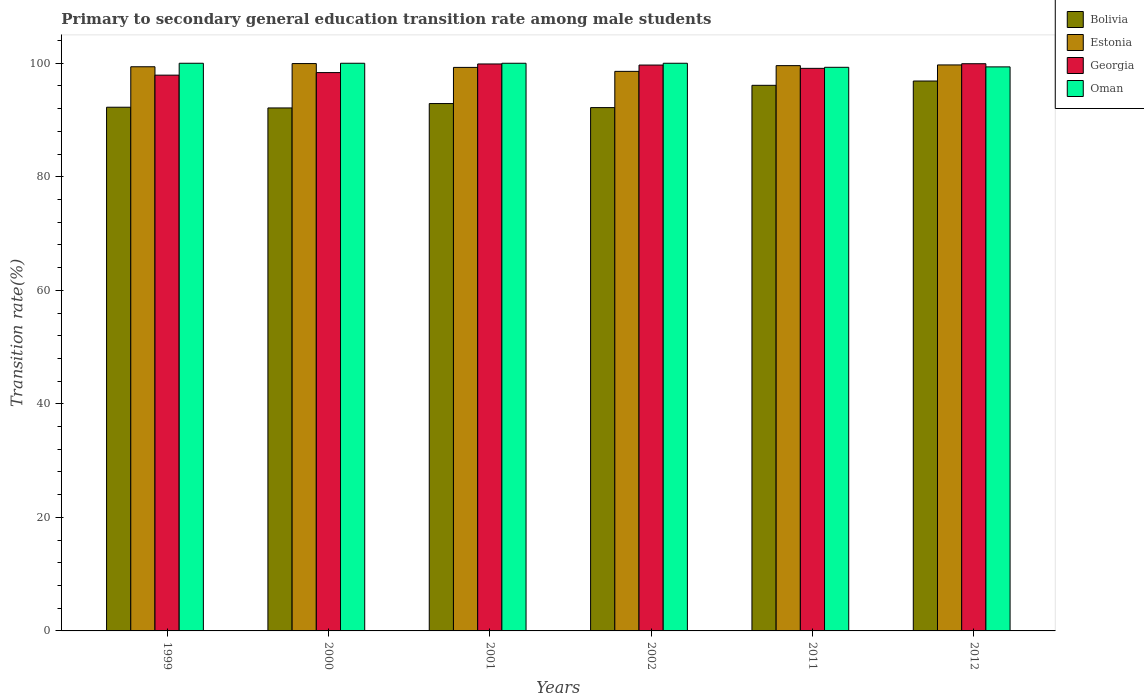How many different coloured bars are there?
Offer a very short reply. 4. How many groups of bars are there?
Give a very brief answer. 6. Are the number of bars per tick equal to the number of legend labels?
Ensure brevity in your answer.  Yes. How many bars are there on the 4th tick from the left?
Make the answer very short. 4. Across all years, what is the maximum transition rate in Estonia?
Your response must be concise. 99.94. Across all years, what is the minimum transition rate in Estonia?
Ensure brevity in your answer.  98.57. What is the total transition rate in Oman in the graph?
Provide a short and direct response. 598.65. What is the difference between the transition rate in Estonia in 2002 and that in 2012?
Make the answer very short. -1.13. What is the difference between the transition rate in Oman in 2011 and the transition rate in Georgia in 1999?
Offer a very short reply. 1.38. What is the average transition rate in Georgia per year?
Keep it short and to the point. 99.14. In the year 2002, what is the difference between the transition rate in Bolivia and transition rate in Georgia?
Keep it short and to the point. -7.5. In how many years, is the transition rate in Estonia greater than 24 %?
Make the answer very short. 6. What is the ratio of the transition rate in Bolivia in 1999 to that in 2011?
Make the answer very short. 0.96. What is the difference between the highest and the second highest transition rate in Bolivia?
Your answer should be very brief. 0.76. What is the difference between the highest and the lowest transition rate in Oman?
Your answer should be compact. 0.71. In how many years, is the transition rate in Estonia greater than the average transition rate in Estonia taken over all years?
Your response must be concise. 3. Is the sum of the transition rate in Georgia in 2001 and 2011 greater than the maximum transition rate in Estonia across all years?
Provide a succinct answer. Yes. Is it the case that in every year, the sum of the transition rate in Bolivia and transition rate in Oman is greater than the sum of transition rate in Georgia and transition rate in Estonia?
Keep it short and to the point. No. What does the 1st bar from the left in 1999 represents?
Ensure brevity in your answer.  Bolivia. What does the 2nd bar from the right in 1999 represents?
Offer a very short reply. Georgia. Is it the case that in every year, the sum of the transition rate in Georgia and transition rate in Oman is greater than the transition rate in Estonia?
Offer a very short reply. Yes. How many bars are there?
Provide a short and direct response. 24. Are all the bars in the graph horizontal?
Your response must be concise. No. Does the graph contain any zero values?
Your answer should be compact. No. Where does the legend appear in the graph?
Ensure brevity in your answer.  Top right. How many legend labels are there?
Ensure brevity in your answer.  4. What is the title of the graph?
Your answer should be compact. Primary to secondary general education transition rate among male students. Does "Turks and Caicos Islands" appear as one of the legend labels in the graph?
Provide a succinct answer. No. What is the label or title of the X-axis?
Offer a terse response. Years. What is the label or title of the Y-axis?
Make the answer very short. Transition rate(%). What is the Transition rate(%) in Bolivia in 1999?
Provide a short and direct response. 92.25. What is the Transition rate(%) of Estonia in 1999?
Ensure brevity in your answer.  99.38. What is the Transition rate(%) of Georgia in 1999?
Make the answer very short. 97.91. What is the Transition rate(%) in Oman in 1999?
Give a very brief answer. 100. What is the Transition rate(%) of Bolivia in 2000?
Ensure brevity in your answer.  92.13. What is the Transition rate(%) in Estonia in 2000?
Your response must be concise. 99.94. What is the Transition rate(%) of Georgia in 2000?
Offer a very short reply. 98.36. What is the Transition rate(%) in Oman in 2000?
Provide a succinct answer. 100. What is the Transition rate(%) of Bolivia in 2001?
Give a very brief answer. 92.9. What is the Transition rate(%) in Estonia in 2001?
Provide a short and direct response. 99.27. What is the Transition rate(%) in Georgia in 2001?
Make the answer very short. 99.88. What is the Transition rate(%) of Oman in 2001?
Ensure brevity in your answer.  100. What is the Transition rate(%) in Bolivia in 2002?
Provide a short and direct response. 92.19. What is the Transition rate(%) in Estonia in 2002?
Make the answer very short. 98.57. What is the Transition rate(%) in Georgia in 2002?
Provide a succinct answer. 99.68. What is the Transition rate(%) of Bolivia in 2011?
Your response must be concise. 96.11. What is the Transition rate(%) in Estonia in 2011?
Provide a short and direct response. 99.58. What is the Transition rate(%) of Georgia in 2011?
Provide a short and direct response. 99.1. What is the Transition rate(%) of Oman in 2011?
Give a very brief answer. 99.29. What is the Transition rate(%) in Bolivia in 2012?
Your answer should be very brief. 96.87. What is the Transition rate(%) of Estonia in 2012?
Offer a very short reply. 99.71. What is the Transition rate(%) in Georgia in 2012?
Make the answer very short. 99.92. What is the Transition rate(%) of Oman in 2012?
Your answer should be very brief. 99.36. Across all years, what is the maximum Transition rate(%) of Bolivia?
Make the answer very short. 96.87. Across all years, what is the maximum Transition rate(%) in Estonia?
Make the answer very short. 99.94. Across all years, what is the maximum Transition rate(%) of Georgia?
Your answer should be very brief. 99.92. Across all years, what is the maximum Transition rate(%) of Oman?
Provide a succinct answer. 100. Across all years, what is the minimum Transition rate(%) in Bolivia?
Your response must be concise. 92.13. Across all years, what is the minimum Transition rate(%) of Estonia?
Provide a short and direct response. 98.57. Across all years, what is the minimum Transition rate(%) of Georgia?
Ensure brevity in your answer.  97.91. Across all years, what is the minimum Transition rate(%) in Oman?
Make the answer very short. 99.29. What is the total Transition rate(%) of Bolivia in the graph?
Offer a terse response. 562.46. What is the total Transition rate(%) of Estonia in the graph?
Provide a short and direct response. 596.46. What is the total Transition rate(%) in Georgia in the graph?
Offer a very short reply. 594.84. What is the total Transition rate(%) of Oman in the graph?
Ensure brevity in your answer.  598.65. What is the difference between the Transition rate(%) of Bolivia in 1999 and that in 2000?
Offer a terse response. 0.13. What is the difference between the Transition rate(%) in Estonia in 1999 and that in 2000?
Make the answer very short. -0.56. What is the difference between the Transition rate(%) of Georgia in 1999 and that in 2000?
Your response must be concise. -0.45. What is the difference between the Transition rate(%) of Oman in 1999 and that in 2000?
Offer a very short reply. 0. What is the difference between the Transition rate(%) in Bolivia in 1999 and that in 2001?
Give a very brief answer. -0.65. What is the difference between the Transition rate(%) in Estonia in 1999 and that in 2001?
Provide a short and direct response. 0.11. What is the difference between the Transition rate(%) in Georgia in 1999 and that in 2001?
Provide a short and direct response. -1.97. What is the difference between the Transition rate(%) of Bolivia in 1999 and that in 2002?
Your answer should be very brief. 0.06. What is the difference between the Transition rate(%) in Estonia in 1999 and that in 2002?
Ensure brevity in your answer.  0.81. What is the difference between the Transition rate(%) in Georgia in 1999 and that in 2002?
Your answer should be very brief. -1.78. What is the difference between the Transition rate(%) of Bolivia in 1999 and that in 2011?
Provide a succinct answer. -3.86. What is the difference between the Transition rate(%) of Estonia in 1999 and that in 2011?
Your answer should be compact. -0.2. What is the difference between the Transition rate(%) of Georgia in 1999 and that in 2011?
Ensure brevity in your answer.  -1.2. What is the difference between the Transition rate(%) of Oman in 1999 and that in 2011?
Provide a succinct answer. 0.71. What is the difference between the Transition rate(%) in Bolivia in 1999 and that in 2012?
Provide a succinct answer. -4.62. What is the difference between the Transition rate(%) of Estonia in 1999 and that in 2012?
Provide a succinct answer. -0.32. What is the difference between the Transition rate(%) of Georgia in 1999 and that in 2012?
Provide a succinct answer. -2.01. What is the difference between the Transition rate(%) of Oman in 1999 and that in 2012?
Keep it short and to the point. 0.64. What is the difference between the Transition rate(%) in Bolivia in 2000 and that in 2001?
Give a very brief answer. -0.77. What is the difference between the Transition rate(%) of Estonia in 2000 and that in 2001?
Give a very brief answer. 0.67. What is the difference between the Transition rate(%) of Georgia in 2000 and that in 2001?
Ensure brevity in your answer.  -1.52. What is the difference between the Transition rate(%) in Oman in 2000 and that in 2001?
Make the answer very short. 0. What is the difference between the Transition rate(%) in Bolivia in 2000 and that in 2002?
Give a very brief answer. -0.06. What is the difference between the Transition rate(%) of Estonia in 2000 and that in 2002?
Your response must be concise. 1.37. What is the difference between the Transition rate(%) in Georgia in 2000 and that in 2002?
Ensure brevity in your answer.  -1.33. What is the difference between the Transition rate(%) in Bolivia in 2000 and that in 2011?
Your answer should be very brief. -3.99. What is the difference between the Transition rate(%) of Estonia in 2000 and that in 2011?
Give a very brief answer. 0.36. What is the difference between the Transition rate(%) in Georgia in 2000 and that in 2011?
Give a very brief answer. -0.74. What is the difference between the Transition rate(%) in Oman in 2000 and that in 2011?
Offer a terse response. 0.71. What is the difference between the Transition rate(%) of Bolivia in 2000 and that in 2012?
Offer a very short reply. -4.74. What is the difference between the Transition rate(%) of Estonia in 2000 and that in 2012?
Provide a succinct answer. 0.24. What is the difference between the Transition rate(%) in Georgia in 2000 and that in 2012?
Make the answer very short. -1.56. What is the difference between the Transition rate(%) of Oman in 2000 and that in 2012?
Offer a terse response. 0.64. What is the difference between the Transition rate(%) of Bolivia in 2001 and that in 2002?
Ensure brevity in your answer.  0.71. What is the difference between the Transition rate(%) in Estonia in 2001 and that in 2002?
Your answer should be compact. 0.7. What is the difference between the Transition rate(%) of Georgia in 2001 and that in 2002?
Offer a very short reply. 0.19. What is the difference between the Transition rate(%) in Bolivia in 2001 and that in 2011?
Offer a very short reply. -3.21. What is the difference between the Transition rate(%) in Estonia in 2001 and that in 2011?
Make the answer very short. -0.31. What is the difference between the Transition rate(%) of Georgia in 2001 and that in 2011?
Your response must be concise. 0.77. What is the difference between the Transition rate(%) of Oman in 2001 and that in 2011?
Your answer should be very brief. 0.71. What is the difference between the Transition rate(%) in Bolivia in 2001 and that in 2012?
Provide a succinct answer. -3.97. What is the difference between the Transition rate(%) of Estonia in 2001 and that in 2012?
Offer a terse response. -0.44. What is the difference between the Transition rate(%) in Georgia in 2001 and that in 2012?
Your answer should be compact. -0.04. What is the difference between the Transition rate(%) of Oman in 2001 and that in 2012?
Offer a very short reply. 0.64. What is the difference between the Transition rate(%) of Bolivia in 2002 and that in 2011?
Ensure brevity in your answer.  -3.92. What is the difference between the Transition rate(%) in Estonia in 2002 and that in 2011?
Make the answer very short. -1.01. What is the difference between the Transition rate(%) of Georgia in 2002 and that in 2011?
Your response must be concise. 0.58. What is the difference between the Transition rate(%) in Oman in 2002 and that in 2011?
Ensure brevity in your answer.  0.71. What is the difference between the Transition rate(%) in Bolivia in 2002 and that in 2012?
Your answer should be compact. -4.68. What is the difference between the Transition rate(%) in Estonia in 2002 and that in 2012?
Make the answer very short. -1.13. What is the difference between the Transition rate(%) in Georgia in 2002 and that in 2012?
Keep it short and to the point. -0.23. What is the difference between the Transition rate(%) of Oman in 2002 and that in 2012?
Provide a short and direct response. 0.64. What is the difference between the Transition rate(%) of Bolivia in 2011 and that in 2012?
Provide a short and direct response. -0.76. What is the difference between the Transition rate(%) in Estonia in 2011 and that in 2012?
Your response must be concise. -0.12. What is the difference between the Transition rate(%) in Georgia in 2011 and that in 2012?
Your answer should be very brief. -0.82. What is the difference between the Transition rate(%) in Oman in 2011 and that in 2012?
Offer a very short reply. -0.08. What is the difference between the Transition rate(%) of Bolivia in 1999 and the Transition rate(%) of Estonia in 2000?
Your answer should be very brief. -7.69. What is the difference between the Transition rate(%) of Bolivia in 1999 and the Transition rate(%) of Georgia in 2000?
Your answer should be compact. -6.1. What is the difference between the Transition rate(%) of Bolivia in 1999 and the Transition rate(%) of Oman in 2000?
Your answer should be compact. -7.75. What is the difference between the Transition rate(%) in Estonia in 1999 and the Transition rate(%) in Georgia in 2000?
Your answer should be very brief. 1.02. What is the difference between the Transition rate(%) in Estonia in 1999 and the Transition rate(%) in Oman in 2000?
Offer a very short reply. -0.62. What is the difference between the Transition rate(%) of Georgia in 1999 and the Transition rate(%) of Oman in 2000?
Your answer should be compact. -2.09. What is the difference between the Transition rate(%) in Bolivia in 1999 and the Transition rate(%) in Estonia in 2001?
Offer a terse response. -7.02. What is the difference between the Transition rate(%) in Bolivia in 1999 and the Transition rate(%) in Georgia in 2001?
Your answer should be compact. -7.62. What is the difference between the Transition rate(%) in Bolivia in 1999 and the Transition rate(%) in Oman in 2001?
Keep it short and to the point. -7.75. What is the difference between the Transition rate(%) in Estonia in 1999 and the Transition rate(%) in Georgia in 2001?
Keep it short and to the point. -0.49. What is the difference between the Transition rate(%) in Estonia in 1999 and the Transition rate(%) in Oman in 2001?
Make the answer very short. -0.62. What is the difference between the Transition rate(%) in Georgia in 1999 and the Transition rate(%) in Oman in 2001?
Give a very brief answer. -2.09. What is the difference between the Transition rate(%) in Bolivia in 1999 and the Transition rate(%) in Estonia in 2002?
Ensure brevity in your answer.  -6.32. What is the difference between the Transition rate(%) in Bolivia in 1999 and the Transition rate(%) in Georgia in 2002?
Offer a terse response. -7.43. What is the difference between the Transition rate(%) in Bolivia in 1999 and the Transition rate(%) in Oman in 2002?
Give a very brief answer. -7.75. What is the difference between the Transition rate(%) of Estonia in 1999 and the Transition rate(%) of Georgia in 2002?
Offer a very short reply. -0.3. What is the difference between the Transition rate(%) in Estonia in 1999 and the Transition rate(%) in Oman in 2002?
Provide a short and direct response. -0.62. What is the difference between the Transition rate(%) of Georgia in 1999 and the Transition rate(%) of Oman in 2002?
Keep it short and to the point. -2.09. What is the difference between the Transition rate(%) in Bolivia in 1999 and the Transition rate(%) in Estonia in 2011?
Offer a very short reply. -7.33. What is the difference between the Transition rate(%) in Bolivia in 1999 and the Transition rate(%) in Georgia in 2011?
Give a very brief answer. -6.85. What is the difference between the Transition rate(%) in Bolivia in 1999 and the Transition rate(%) in Oman in 2011?
Ensure brevity in your answer.  -7.03. What is the difference between the Transition rate(%) in Estonia in 1999 and the Transition rate(%) in Georgia in 2011?
Provide a succinct answer. 0.28. What is the difference between the Transition rate(%) of Estonia in 1999 and the Transition rate(%) of Oman in 2011?
Your answer should be very brief. 0.1. What is the difference between the Transition rate(%) of Georgia in 1999 and the Transition rate(%) of Oman in 2011?
Keep it short and to the point. -1.38. What is the difference between the Transition rate(%) of Bolivia in 1999 and the Transition rate(%) of Estonia in 2012?
Provide a short and direct response. -7.45. What is the difference between the Transition rate(%) in Bolivia in 1999 and the Transition rate(%) in Georgia in 2012?
Provide a short and direct response. -7.66. What is the difference between the Transition rate(%) of Bolivia in 1999 and the Transition rate(%) of Oman in 2012?
Offer a very short reply. -7.11. What is the difference between the Transition rate(%) in Estonia in 1999 and the Transition rate(%) in Georgia in 2012?
Keep it short and to the point. -0.54. What is the difference between the Transition rate(%) in Estonia in 1999 and the Transition rate(%) in Oman in 2012?
Provide a short and direct response. 0.02. What is the difference between the Transition rate(%) of Georgia in 1999 and the Transition rate(%) of Oman in 2012?
Ensure brevity in your answer.  -1.46. What is the difference between the Transition rate(%) of Bolivia in 2000 and the Transition rate(%) of Estonia in 2001?
Offer a very short reply. -7.14. What is the difference between the Transition rate(%) in Bolivia in 2000 and the Transition rate(%) in Georgia in 2001?
Keep it short and to the point. -7.75. What is the difference between the Transition rate(%) in Bolivia in 2000 and the Transition rate(%) in Oman in 2001?
Keep it short and to the point. -7.87. What is the difference between the Transition rate(%) in Estonia in 2000 and the Transition rate(%) in Georgia in 2001?
Make the answer very short. 0.07. What is the difference between the Transition rate(%) in Estonia in 2000 and the Transition rate(%) in Oman in 2001?
Make the answer very short. -0.06. What is the difference between the Transition rate(%) in Georgia in 2000 and the Transition rate(%) in Oman in 2001?
Give a very brief answer. -1.64. What is the difference between the Transition rate(%) in Bolivia in 2000 and the Transition rate(%) in Estonia in 2002?
Keep it short and to the point. -6.45. What is the difference between the Transition rate(%) of Bolivia in 2000 and the Transition rate(%) of Georgia in 2002?
Keep it short and to the point. -7.56. What is the difference between the Transition rate(%) of Bolivia in 2000 and the Transition rate(%) of Oman in 2002?
Offer a very short reply. -7.87. What is the difference between the Transition rate(%) in Estonia in 2000 and the Transition rate(%) in Georgia in 2002?
Make the answer very short. 0.26. What is the difference between the Transition rate(%) of Estonia in 2000 and the Transition rate(%) of Oman in 2002?
Your response must be concise. -0.06. What is the difference between the Transition rate(%) in Georgia in 2000 and the Transition rate(%) in Oman in 2002?
Your answer should be very brief. -1.64. What is the difference between the Transition rate(%) of Bolivia in 2000 and the Transition rate(%) of Estonia in 2011?
Your response must be concise. -7.46. What is the difference between the Transition rate(%) of Bolivia in 2000 and the Transition rate(%) of Georgia in 2011?
Give a very brief answer. -6.98. What is the difference between the Transition rate(%) in Bolivia in 2000 and the Transition rate(%) in Oman in 2011?
Keep it short and to the point. -7.16. What is the difference between the Transition rate(%) of Estonia in 2000 and the Transition rate(%) of Georgia in 2011?
Give a very brief answer. 0.84. What is the difference between the Transition rate(%) in Estonia in 2000 and the Transition rate(%) in Oman in 2011?
Keep it short and to the point. 0.66. What is the difference between the Transition rate(%) in Georgia in 2000 and the Transition rate(%) in Oman in 2011?
Keep it short and to the point. -0.93. What is the difference between the Transition rate(%) of Bolivia in 2000 and the Transition rate(%) of Estonia in 2012?
Provide a short and direct response. -7.58. What is the difference between the Transition rate(%) of Bolivia in 2000 and the Transition rate(%) of Georgia in 2012?
Provide a succinct answer. -7.79. What is the difference between the Transition rate(%) of Bolivia in 2000 and the Transition rate(%) of Oman in 2012?
Make the answer very short. -7.24. What is the difference between the Transition rate(%) of Estonia in 2000 and the Transition rate(%) of Georgia in 2012?
Offer a very short reply. 0.03. What is the difference between the Transition rate(%) of Estonia in 2000 and the Transition rate(%) of Oman in 2012?
Your answer should be very brief. 0.58. What is the difference between the Transition rate(%) of Georgia in 2000 and the Transition rate(%) of Oman in 2012?
Your answer should be very brief. -1. What is the difference between the Transition rate(%) in Bolivia in 2001 and the Transition rate(%) in Estonia in 2002?
Provide a succinct answer. -5.67. What is the difference between the Transition rate(%) in Bolivia in 2001 and the Transition rate(%) in Georgia in 2002?
Keep it short and to the point. -6.78. What is the difference between the Transition rate(%) in Bolivia in 2001 and the Transition rate(%) in Oman in 2002?
Ensure brevity in your answer.  -7.1. What is the difference between the Transition rate(%) in Estonia in 2001 and the Transition rate(%) in Georgia in 2002?
Ensure brevity in your answer.  -0.41. What is the difference between the Transition rate(%) of Estonia in 2001 and the Transition rate(%) of Oman in 2002?
Your response must be concise. -0.73. What is the difference between the Transition rate(%) in Georgia in 2001 and the Transition rate(%) in Oman in 2002?
Your answer should be very brief. -0.12. What is the difference between the Transition rate(%) in Bolivia in 2001 and the Transition rate(%) in Estonia in 2011?
Make the answer very short. -6.68. What is the difference between the Transition rate(%) of Bolivia in 2001 and the Transition rate(%) of Georgia in 2011?
Your answer should be very brief. -6.2. What is the difference between the Transition rate(%) of Bolivia in 2001 and the Transition rate(%) of Oman in 2011?
Make the answer very short. -6.39. What is the difference between the Transition rate(%) of Estonia in 2001 and the Transition rate(%) of Georgia in 2011?
Your response must be concise. 0.17. What is the difference between the Transition rate(%) of Estonia in 2001 and the Transition rate(%) of Oman in 2011?
Offer a terse response. -0.02. What is the difference between the Transition rate(%) of Georgia in 2001 and the Transition rate(%) of Oman in 2011?
Your response must be concise. 0.59. What is the difference between the Transition rate(%) of Bolivia in 2001 and the Transition rate(%) of Estonia in 2012?
Your response must be concise. -6.8. What is the difference between the Transition rate(%) of Bolivia in 2001 and the Transition rate(%) of Georgia in 2012?
Your answer should be compact. -7.02. What is the difference between the Transition rate(%) in Bolivia in 2001 and the Transition rate(%) in Oman in 2012?
Offer a very short reply. -6.46. What is the difference between the Transition rate(%) in Estonia in 2001 and the Transition rate(%) in Georgia in 2012?
Offer a very short reply. -0.65. What is the difference between the Transition rate(%) of Estonia in 2001 and the Transition rate(%) of Oman in 2012?
Make the answer very short. -0.09. What is the difference between the Transition rate(%) of Georgia in 2001 and the Transition rate(%) of Oman in 2012?
Offer a very short reply. 0.51. What is the difference between the Transition rate(%) of Bolivia in 2002 and the Transition rate(%) of Estonia in 2011?
Make the answer very short. -7.39. What is the difference between the Transition rate(%) of Bolivia in 2002 and the Transition rate(%) of Georgia in 2011?
Your answer should be compact. -6.91. What is the difference between the Transition rate(%) in Bolivia in 2002 and the Transition rate(%) in Oman in 2011?
Give a very brief answer. -7.1. What is the difference between the Transition rate(%) of Estonia in 2002 and the Transition rate(%) of Georgia in 2011?
Ensure brevity in your answer.  -0.53. What is the difference between the Transition rate(%) in Estonia in 2002 and the Transition rate(%) in Oman in 2011?
Provide a succinct answer. -0.72. What is the difference between the Transition rate(%) in Georgia in 2002 and the Transition rate(%) in Oman in 2011?
Your answer should be compact. 0.4. What is the difference between the Transition rate(%) of Bolivia in 2002 and the Transition rate(%) of Estonia in 2012?
Your response must be concise. -7.52. What is the difference between the Transition rate(%) in Bolivia in 2002 and the Transition rate(%) in Georgia in 2012?
Ensure brevity in your answer.  -7.73. What is the difference between the Transition rate(%) in Bolivia in 2002 and the Transition rate(%) in Oman in 2012?
Keep it short and to the point. -7.17. What is the difference between the Transition rate(%) in Estonia in 2002 and the Transition rate(%) in Georgia in 2012?
Your answer should be compact. -1.35. What is the difference between the Transition rate(%) of Estonia in 2002 and the Transition rate(%) of Oman in 2012?
Provide a succinct answer. -0.79. What is the difference between the Transition rate(%) of Georgia in 2002 and the Transition rate(%) of Oman in 2012?
Keep it short and to the point. 0.32. What is the difference between the Transition rate(%) of Bolivia in 2011 and the Transition rate(%) of Estonia in 2012?
Your response must be concise. -3.59. What is the difference between the Transition rate(%) of Bolivia in 2011 and the Transition rate(%) of Georgia in 2012?
Offer a very short reply. -3.8. What is the difference between the Transition rate(%) in Bolivia in 2011 and the Transition rate(%) in Oman in 2012?
Offer a very short reply. -3.25. What is the difference between the Transition rate(%) of Estonia in 2011 and the Transition rate(%) of Georgia in 2012?
Keep it short and to the point. -0.34. What is the difference between the Transition rate(%) in Estonia in 2011 and the Transition rate(%) in Oman in 2012?
Ensure brevity in your answer.  0.22. What is the difference between the Transition rate(%) of Georgia in 2011 and the Transition rate(%) of Oman in 2012?
Offer a very short reply. -0.26. What is the average Transition rate(%) in Bolivia per year?
Provide a short and direct response. 93.74. What is the average Transition rate(%) in Estonia per year?
Offer a very short reply. 99.41. What is the average Transition rate(%) of Georgia per year?
Offer a terse response. 99.14. What is the average Transition rate(%) of Oman per year?
Give a very brief answer. 99.77. In the year 1999, what is the difference between the Transition rate(%) of Bolivia and Transition rate(%) of Estonia?
Offer a very short reply. -7.13. In the year 1999, what is the difference between the Transition rate(%) of Bolivia and Transition rate(%) of Georgia?
Provide a short and direct response. -5.65. In the year 1999, what is the difference between the Transition rate(%) in Bolivia and Transition rate(%) in Oman?
Offer a terse response. -7.75. In the year 1999, what is the difference between the Transition rate(%) of Estonia and Transition rate(%) of Georgia?
Give a very brief answer. 1.48. In the year 1999, what is the difference between the Transition rate(%) of Estonia and Transition rate(%) of Oman?
Keep it short and to the point. -0.62. In the year 1999, what is the difference between the Transition rate(%) of Georgia and Transition rate(%) of Oman?
Give a very brief answer. -2.09. In the year 2000, what is the difference between the Transition rate(%) in Bolivia and Transition rate(%) in Estonia?
Provide a succinct answer. -7.82. In the year 2000, what is the difference between the Transition rate(%) in Bolivia and Transition rate(%) in Georgia?
Ensure brevity in your answer.  -6.23. In the year 2000, what is the difference between the Transition rate(%) of Bolivia and Transition rate(%) of Oman?
Give a very brief answer. -7.87. In the year 2000, what is the difference between the Transition rate(%) in Estonia and Transition rate(%) in Georgia?
Provide a succinct answer. 1.59. In the year 2000, what is the difference between the Transition rate(%) of Estonia and Transition rate(%) of Oman?
Offer a very short reply. -0.06. In the year 2000, what is the difference between the Transition rate(%) of Georgia and Transition rate(%) of Oman?
Offer a very short reply. -1.64. In the year 2001, what is the difference between the Transition rate(%) in Bolivia and Transition rate(%) in Estonia?
Offer a terse response. -6.37. In the year 2001, what is the difference between the Transition rate(%) in Bolivia and Transition rate(%) in Georgia?
Your answer should be compact. -6.97. In the year 2001, what is the difference between the Transition rate(%) in Bolivia and Transition rate(%) in Oman?
Your response must be concise. -7.1. In the year 2001, what is the difference between the Transition rate(%) of Estonia and Transition rate(%) of Georgia?
Keep it short and to the point. -0.6. In the year 2001, what is the difference between the Transition rate(%) of Estonia and Transition rate(%) of Oman?
Keep it short and to the point. -0.73. In the year 2001, what is the difference between the Transition rate(%) of Georgia and Transition rate(%) of Oman?
Offer a very short reply. -0.12. In the year 2002, what is the difference between the Transition rate(%) in Bolivia and Transition rate(%) in Estonia?
Give a very brief answer. -6.38. In the year 2002, what is the difference between the Transition rate(%) in Bolivia and Transition rate(%) in Georgia?
Provide a short and direct response. -7.5. In the year 2002, what is the difference between the Transition rate(%) of Bolivia and Transition rate(%) of Oman?
Provide a short and direct response. -7.81. In the year 2002, what is the difference between the Transition rate(%) in Estonia and Transition rate(%) in Georgia?
Your answer should be compact. -1.11. In the year 2002, what is the difference between the Transition rate(%) of Estonia and Transition rate(%) of Oman?
Keep it short and to the point. -1.43. In the year 2002, what is the difference between the Transition rate(%) of Georgia and Transition rate(%) of Oman?
Your answer should be compact. -0.32. In the year 2011, what is the difference between the Transition rate(%) of Bolivia and Transition rate(%) of Estonia?
Your answer should be compact. -3.47. In the year 2011, what is the difference between the Transition rate(%) of Bolivia and Transition rate(%) of Georgia?
Your answer should be very brief. -2.99. In the year 2011, what is the difference between the Transition rate(%) in Bolivia and Transition rate(%) in Oman?
Your response must be concise. -3.17. In the year 2011, what is the difference between the Transition rate(%) in Estonia and Transition rate(%) in Georgia?
Offer a terse response. 0.48. In the year 2011, what is the difference between the Transition rate(%) of Estonia and Transition rate(%) of Oman?
Offer a terse response. 0.3. In the year 2011, what is the difference between the Transition rate(%) of Georgia and Transition rate(%) of Oman?
Give a very brief answer. -0.18. In the year 2012, what is the difference between the Transition rate(%) in Bolivia and Transition rate(%) in Estonia?
Your answer should be compact. -2.84. In the year 2012, what is the difference between the Transition rate(%) in Bolivia and Transition rate(%) in Georgia?
Make the answer very short. -3.05. In the year 2012, what is the difference between the Transition rate(%) of Bolivia and Transition rate(%) of Oman?
Make the answer very short. -2.49. In the year 2012, what is the difference between the Transition rate(%) of Estonia and Transition rate(%) of Georgia?
Your response must be concise. -0.21. In the year 2012, what is the difference between the Transition rate(%) in Estonia and Transition rate(%) in Oman?
Ensure brevity in your answer.  0.34. In the year 2012, what is the difference between the Transition rate(%) of Georgia and Transition rate(%) of Oman?
Ensure brevity in your answer.  0.56. What is the ratio of the Transition rate(%) of Georgia in 1999 to that in 2001?
Make the answer very short. 0.98. What is the ratio of the Transition rate(%) of Bolivia in 1999 to that in 2002?
Your answer should be compact. 1. What is the ratio of the Transition rate(%) of Estonia in 1999 to that in 2002?
Provide a succinct answer. 1.01. What is the ratio of the Transition rate(%) of Georgia in 1999 to that in 2002?
Your answer should be compact. 0.98. What is the ratio of the Transition rate(%) of Bolivia in 1999 to that in 2011?
Your response must be concise. 0.96. What is the ratio of the Transition rate(%) in Georgia in 1999 to that in 2011?
Provide a short and direct response. 0.99. What is the ratio of the Transition rate(%) of Bolivia in 1999 to that in 2012?
Give a very brief answer. 0.95. What is the ratio of the Transition rate(%) in Georgia in 1999 to that in 2012?
Provide a short and direct response. 0.98. What is the ratio of the Transition rate(%) in Oman in 1999 to that in 2012?
Keep it short and to the point. 1.01. What is the ratio of the Transition rate(%) in Estonia in 2000 to that in 2001?
Give a very brief answer. 1.01. What is the ratio of the Transition rate(%) of Georgia in 2000 to that in 2001?
Provide a succinct answer. 0.98. What is the ratio of the Transition rate(%) of Estonia in 2000 to that in 2002?
Give a very brief answer. 1.01. What is the ratio of the Transition rate(%) of Georgia in 2000 to that in 2002?
Keep it short and to the point. 0.99. What is the ratio of the Transition rate(%) in Bolivia in 2000 to that in 2011?
Give a very brief answer. 0.96. What is the ratio of the Transition rate(%) of Oman in 2000 to that in 2011?
Offer a terse response. 1.01. What is the ratio of the Transition rate(%) of Bolivia in 2000 to that in 2012?
Your answer should be compact. 0.95. What is the ratio of the Transition rate(%) in Georgia in 2000 to that in 2012?
Ensure brevity in your answer.  0.98. What is the ratio of the Transition rate(%) of Oman in 2000 to that in 2012?
Ensure brevity in your answer.  1.01. What is the ratio of the Transition rate(%) in Bolivia in 2001 to that in 2002?
Ensure brevity in your answer.  1.01. What is the ratio of the Transition rate(%) of Estonia in 2001 to that in 2002?
Your response must be concise. 1.01. What is the ratio of the Transition rate(%) of Georgia in 2001 to that in 2002?
Ensure brevity in your answer.  1. What is the ratio of the Transition rate(%) in Oman in 2001 to that in 2002?
Provide a short and direct response. 1. What is the ratio of the Transition rate(%) of Bolivia in 2001 to that in 2011?
Your answer should be very brief. 0.97. What is the ratio of the Transition rate(%) in Georgia in 2001 to that in 2011?
Provide a short and direct response. 1.01. What is the ratio of the Transition rate(%) in Oman in 2001 to that in 2011?
Provide a succinct answer. 1.01. What is the ratio of the Transition rate(%) in Estonia in 2001 to that in 2012?
Ensure brevity in your answer.  1. What is the ratio of the Transition rate(%) of Georgia in 2001 to that in 2012?
Ensure brevity in your answer.  1. What is the ratio of the Transition rate(%) in Oman in 2001 to that in 2012?
Your answer should be compact. 1.01. What is the ratio of the Transition rate(%) of Bolivia in 2002 to that in 2011?
Offer a very short reply. 0.96. What is the ratio of the Transition rate(%) in Georgia in 2002 to that in 2011?
Ensure brevity in your answer.  1.01. What is the ratio of the Transition rate(%) in Oman in 2002 to that in 2011?
Make the answer very short. 1.01. What is the ratio of the Transition rate(%) of Bolivia in 2002 to that in 2012?
Give a very brief answer. 0.95. What is the ratio of the Transition rate(%) in Oman in 2002 to that in 2012?
Provide a short and direct response. 1.01. What is the ratio of the Transition rate(%) in Oman in 2011 to that in 2012?
Your response must be concise. 1. What is the difference between the highest and the second highest Transition rate(%) in Bolivia?
Provide a succinct answer. 0.76. What is the difference between the highest and the second highest Transition rate(%) of Estonia?
Your answer should be very brief. 0.24. What is the difference between the highest and the second highest Transition rate(%) in Georgia?
Ensure brevity in your answer.  0.04. What is the difference between the highest and the second highest Transition rate(%) of Oman?
Offer a terse response. 0. What is the difference between the highest and the lowest Transition rate(%) of Bolivia?
Offer a terse response. 4.74. What is the difference between the highest and the lowest Transition rate(%) in Estonia?
Provide a short and direct response. 1.37. What is the difference between the highest and the lowest Transition rate(%) of Georgia?
Provide a short and direct response. 2.01. What is the difference between the highest and the lowest Transition rate(%) of Oman?
Your answer should be compact. 0.71. 